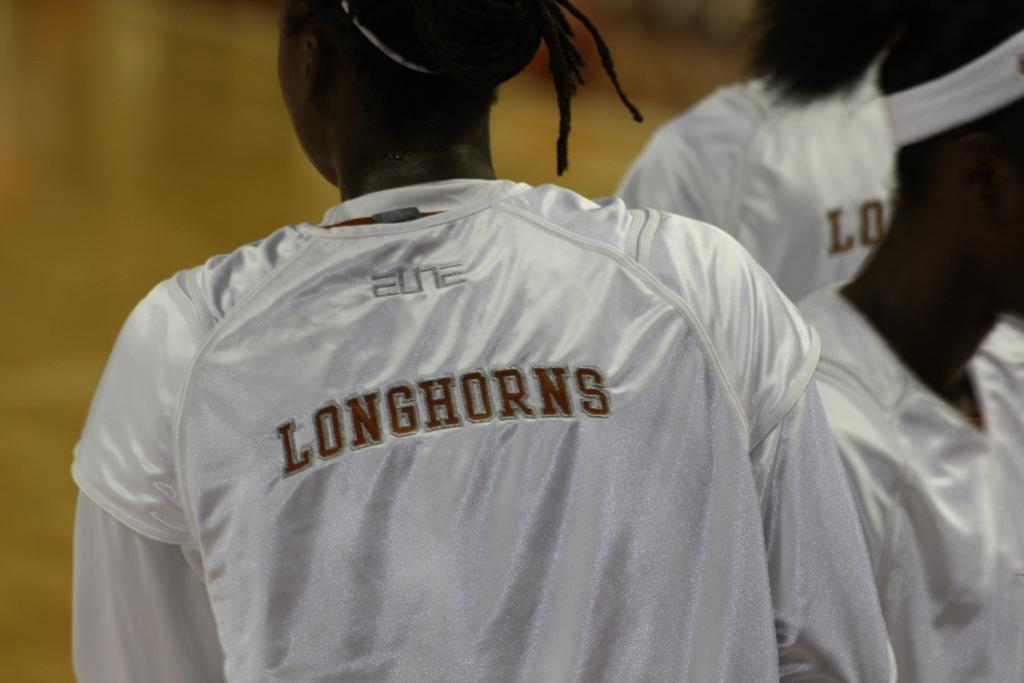Provide a one-sentence caption for the provided image. A black athlete wearing a white jersey with Longhorns written on the back. 